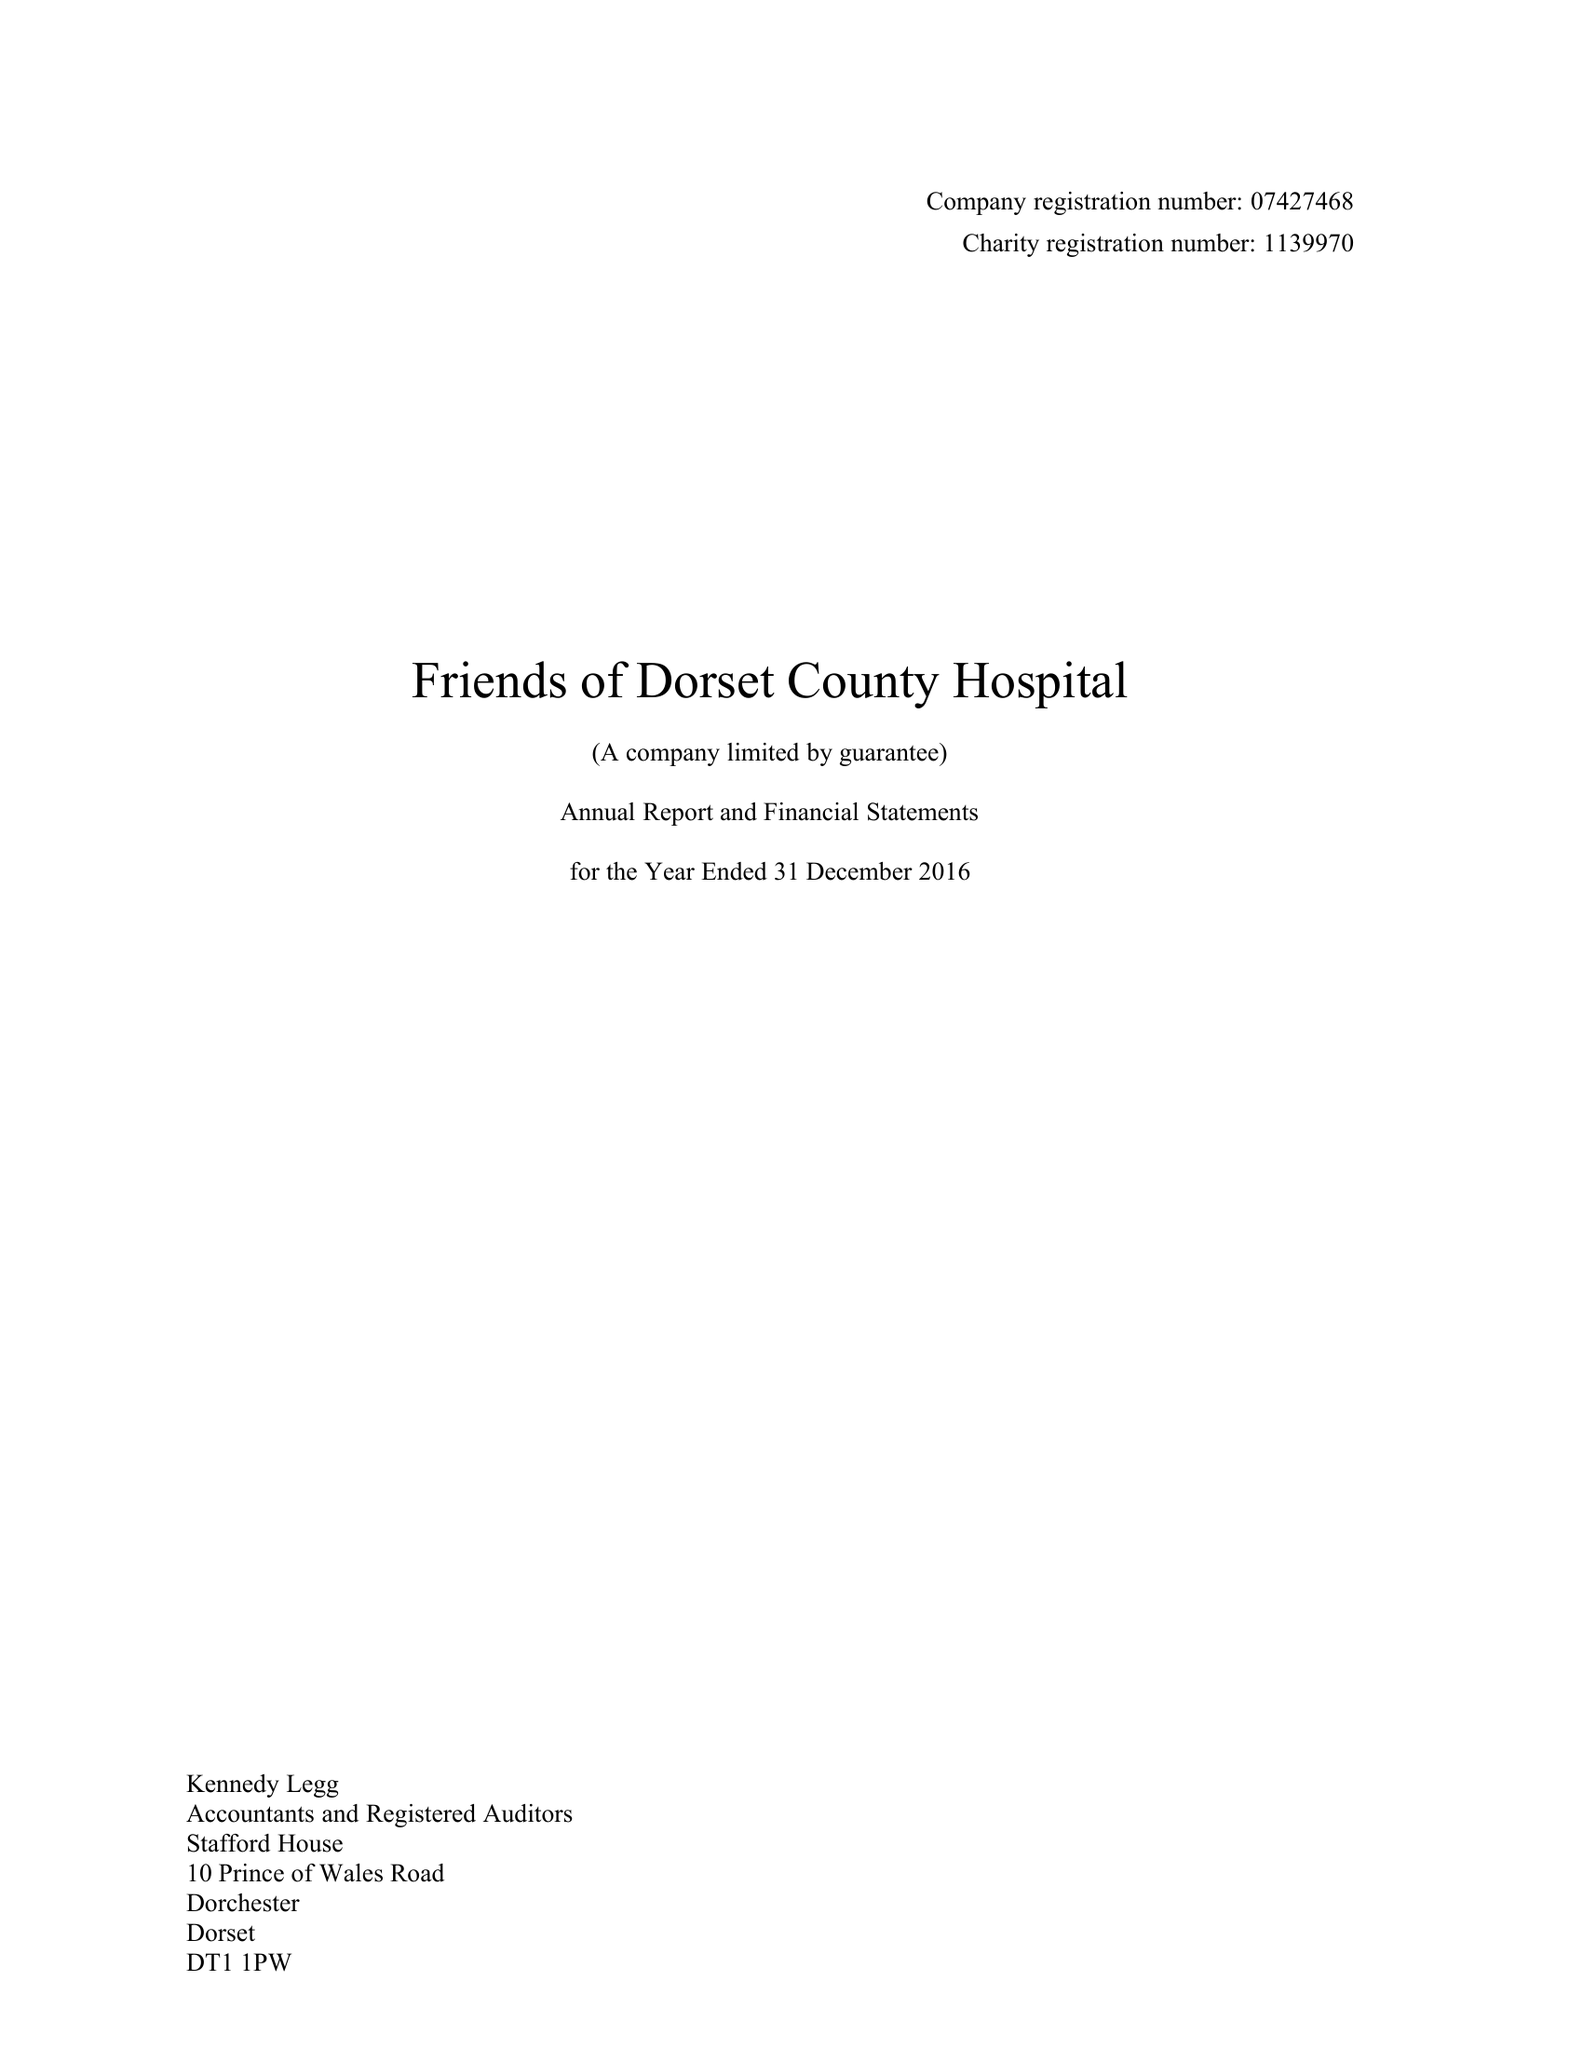What is the value for the address__post_town?
Answer the question using a single word or phrase. DORCHESTER 